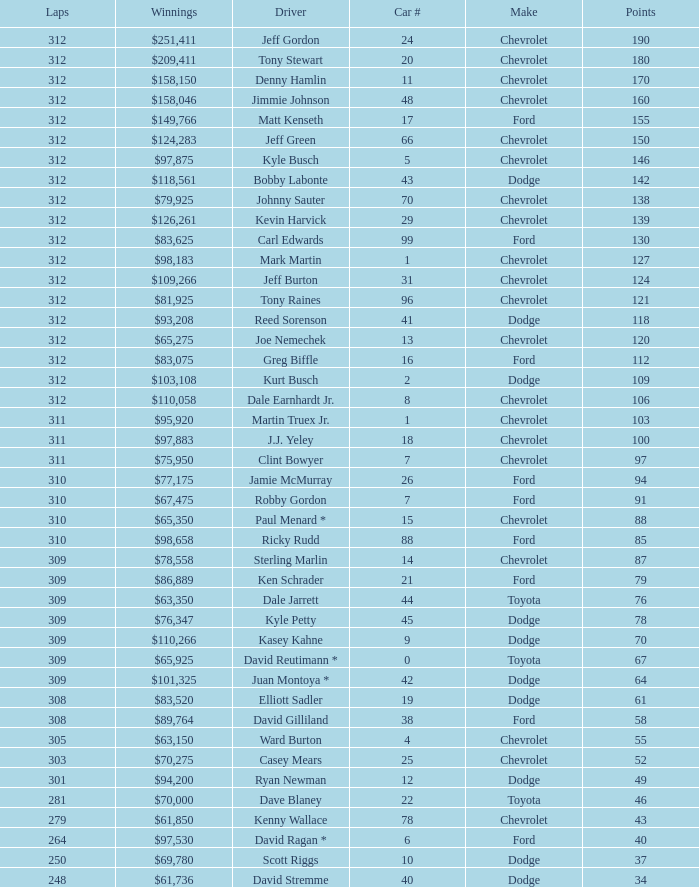What is the sum of laps that has a car number of larger than 1, is a ford, and has 155 points? 312.0. 